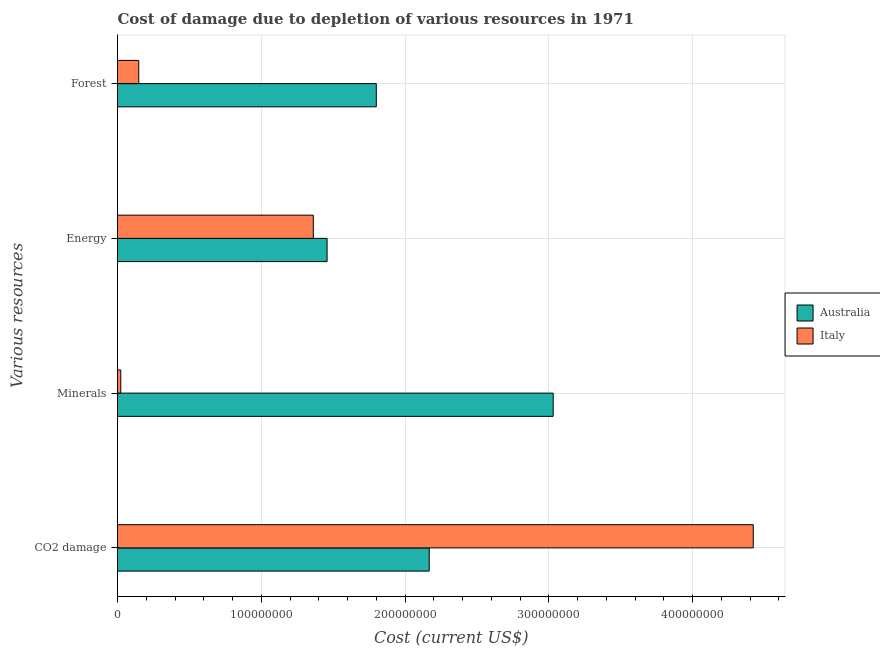How many different coloured bars are there?
Keep it short and to the point. 2. How many bars are there on the 2nd tick from the top?
Provide a succinct answer. 2. How many bars are there on the 2nd tick from the bottom?
Your response must be concise. 2. What is the label of the 3rd group of bars from the top?
Ensure brevity in your answer.  Minerals. What is the cost of damage due to depletion of coal in Australia?
Your answer should be compact. 2.17e+08. Across all countries, what is the maximum cost of damage due to depletion of coal?
Your response must be concise. 4.42e+08. Across all countries, what is the minimum cost of damage due to depletion of energy?
Ensure brevity in your answer.  1.36e+08. In which country was the cost of damage due to depletion of coal maximum?
Your answer should be very brief. Italy. In which country was the cost of damage due to depletion of energy minimum?
Give a very brief answer. Italy. What is the total cost of damage due to depletion of forests in the graph?
Offer a terse response. 1.95e+08. What is the difference between the cost of damage due to depletion of energy in Australia and that in Italy?
Your answer should be very brief. 9.57e+06. What is the difference between the cost of damage due to depletion of energy in Australia and the cost of damage due to depletion of coal in Italy?
Provide a succinct answer. -2.96e+08. What is the average cost of damage due to depletion of energy per country?
Provide a succinct answer. 1.41e+08. What is the difference between the cost of damage due to depletion of forests and cost of damage due to depletion of energy in Italy?
Offer a terse response. -1.21e+08. What is the ratio of the cost of damage due to depletion of coal in Australia to that in Italy?
Give a very brief answer. 0.49. Is the cost of damage due to depletion of coal in Australia less than that in Italy?
Provide a succinct answer. Yes. What is the difference between the highest and the second highest cost of damage due to depletion of minerals?
Provide a short and direct response. 3.01e+08. What is the difference between the highest and the lowest cost of damage due to depletion of coal?
Keep it short and to the point. 2.25e+08. Is the sum of the cost of damage due to depletion of minerals in Australia and Italy greater than the maximum cost of damage due to depletion of energy across all countries?
Offer a very short reply. Yes. Is it the case that in every country, the sum of the cost of damage due to depletion of forests and cost of damage due to depletion of coal is greater than the sum of cost of damage due to depletion of minerals and cost of damage due to depletion of energy?
Make the answer very short. Yes. What does the 2nd bar from the bottom in Energy represents?
Your response must be concise. Italy. Are all the bars in the graph horizontal?
Ensure brevity in your answer.  Yes. How many countries are there in the graph?
Your answer should be very brief. 2. Are the values on the major ticks of X-axis written in scientific E-notation?
Your answer should be compact. No. Does the graph contain any zero values?
Provide a succinct answer. No. What is the title of the graph?
Provide a succinct answer. Cost of damage due to depletion of various resources in 1971 . Does "Kosovo" appear as one of the legend labels in the graph?
Ensure brevity in your answer.  No. What is the label or title of the X-axis?
Your answer should be compact. Cost (current US$). What is the label or title of the Y-axis?
Give a very brief answer. Various resources. What is the Cost (current US$) in Australia in CO2 damage?
Offer a terse response. 2.17e+08. What is the Cost (current US$) of Italy in CO2 damage?
Provide a succinct answer. 4.42e+08. What is the Cost (current US$) of Australia in Minerals?
Your response must be concise. 3.03e+08. What is the Cost (current US$) of Italy in Minerals?
Your response must be concise. 2.28e+06. What is the Cost (current US$) of Australia in Energy?
Offer a terse response. 1.46e+08. What is the Cost (current US$) of Italy in Energy?
Make the answer very short. 1.36e+08. What is the Cost (current US$) in Australia in Forest?
Your response must be concise. 1.80e+08. What is the Cost (current US$) of Italy in Forest?
Your answer should be compact. 1.48e+07. Across all Various resources, what is the maximum Cost (current US$) in Australia?
Ensure brevity in your answer.  3.03e+08. Across all Various resources, what is the maximum Cost (current US$) of Italy?
Provide a short and direct response. 4.42e+08. Across all Various resources, what is the minimum Cost (current US$) of Australia?
Your answer should be compact. 1.46e+08. Across all Various resources, what is the minimum Cost (current US$) of Italy?
Your answer should be compact. 2.28e+06. What is the total Cost (current US$) in Australia in the graph?
Provide a succinct answer. 8.46e+08. What is the total Cost (current US$) of Italy in the graph?
Your answer should be very brief. 5.95e+08. What is the difference between the Cost (current US$) of Australia in CO2 damage and that in Minerals?
Offer a very short reply. -8.62e+07. What is the difference between the Cost (current US$) of Italy in CO2 damage and that in Minerals?
Provide a succinct answer. 4.40e+08. What is the difference between the Cost (current US$) in Australia in CO2 damage and that in Energy?
Keep it short and to the point. 7.10e+07. What is the difference between the Cost (current US$) in Italy in CO2 damage and that in Energy?
Offer a terse response. 3.06e+08. What is the difference between the Cost (current US$) of Australia in CO2 damage and that in Forest?
Give a very brief answer. 3.68e+07. What is the difference between the Cost (current US$) of Italy in CO2 damage and that in Forest?
Your response must be concise. 4.27e+08. What is the difference between the Cost (current US$) in Australia in Minerals and that in Energy?
Provide a short and direct response. 1.57e+08. What is the difference between the Cost (current US$) in Italy in Minerals and that in Energy?
Your response must be concise. -1.34e+08. What is the difference between the Cost (current US$) in Australia in Minerals and that in Forest?
Provide a succinct answer. 1.23e+08. What is the difference between the Cost (current US$) in Italy in Minerals and that in Forest?
Ensure brevity in your answer.  -1.25e+07. What is the difference between the Cost (current US$) of Australia in Energy and that in Forest?
Offer a terse response. -3.42e+07. What is the difference between the Cost (current US$) in Italy in Energy and that in Forest?
Ensure brevity in your answer.  1.21e+08. What is the difference between the Cost (current US$) in Australia in CO2 damage and the Cost (current US$) in Italy in Minerals?
Your answer should be compact. 2.15e+08. What is the difference between the Cost (current US$) of Australia in CO2 damage and the Cost (current US$) of Italy in Energy?
Your answer should be very brief. 8.06e+07. What is the difference between the Cost (current US$) in Australia in CO2 damage and the Cost (current US$) in Italy in Forest?
Make the answer very short. 2.02e+08. What is the difference between the Cost (current US$) of Australia in Minerals and the Cost (current US$) of Italy in Energy?
Provide a succinct answer. 1.67e+08. What is the difference between the Cost (current US$) in Australia in Minerals and the Cost (current US$) in Italy in Forest?
Provide a short and direct response. 2.88e+08. What is the difference between the Cost (current US$) of Australia in Energy and the Cost (current US$) of Italy in Forest?
Give a very brief answer. 1.31e+08. What is the average Cost (current US$) in Australia per Various resources?
Make the answer very short. 2.11e+08. What is the average Cost (current US$) in Italy per Various resources?
Make the answer very short. 1.49e+08. What is the difference between the Cost (current US$) in Australia and Cost (current US$) in Italy in CO2 damage?
Ensure brevity in your answer.  -2.25e+08. What is the difference between the Cost (current US$) of Australia and Cost (current US$) of Italy in Minerals?
Make the answer very short. 3.01e+08. What is the difference between the Cost (current US$) of Australia and Cost (current US$) of Italy in Energy?
Provide a succinct answer. 9.57e+06. What is the difference between the Cost (current US$) in Australia and Cost (current US$) in Italy in Forest?
Keep it short and to the point. 1.65e+08. What is the ratio of the Cost (current US$) of Australia in CO2 damage to that in Minerals?
Provide a short and direct response. 0.72. What is the ratio of the Cost (current US$) in Italy in CO2 damage to that in Minerals?
Provide a short and direct response. 193.94. What is the ratio of the Cost (current US$) of Australia in CO2 damage to that in Energy?
Your response must be concise. 1.49. What is the ratio of the Cost (current US$) of Italy in CO2 damage to that in Energy?
Keep it short and to the point. 3.25. What is the ratio of the Cost (current US$) of Australia in CO2 damage to that in Forest?
Offer a very short reply. 1.2. What is the ratio of the Cost (current US$) of Italy in CO2 damage to that in Forest?
Your response must be concise. 29.9. What is the ratio of the Cost (current US$) of Australia in Minerals to that in Energy?
Your answer should be very brief. 2.08. What is the ratio of the Cost (current US$) of Italy in Minerals to that in Energy?
Give a very brief answer. 0.02. What is the ratio of the Cost (current US$) of Australia in Minerals to that in Forest?
Your answer should be very brief. 1.68. What is the ratio of the Cost (current US$) of Italy in Minerals to that in Forest?
Ensure brevity in your answer.  0.15. What is the ratio of the Cost (current US$) in Australia in Energy to that in Forest?
Offer a terse response. 0.81. What is the ratio of the Cost (current US$) in Italy in Energy to that in Forest?
Provide a short and direct response. 9.21. What is the difference between the highest and the second highest Cost (current US$) of Australia?
Give a very brief answer. 8.62e+07. What is the difference between the highest and the second highest Cost (current US$) in Italy?
Ensure brevity in your answer.  3.06e+08. What is the difference between the highest and the lowest Cost (current US$) of Australia?
Your answer should be very brief. 1.57e+08. What is the difference between the highest and the lowest Cost (current US$) in Italy?
Keep it short and to the point. 4.40e+08. 